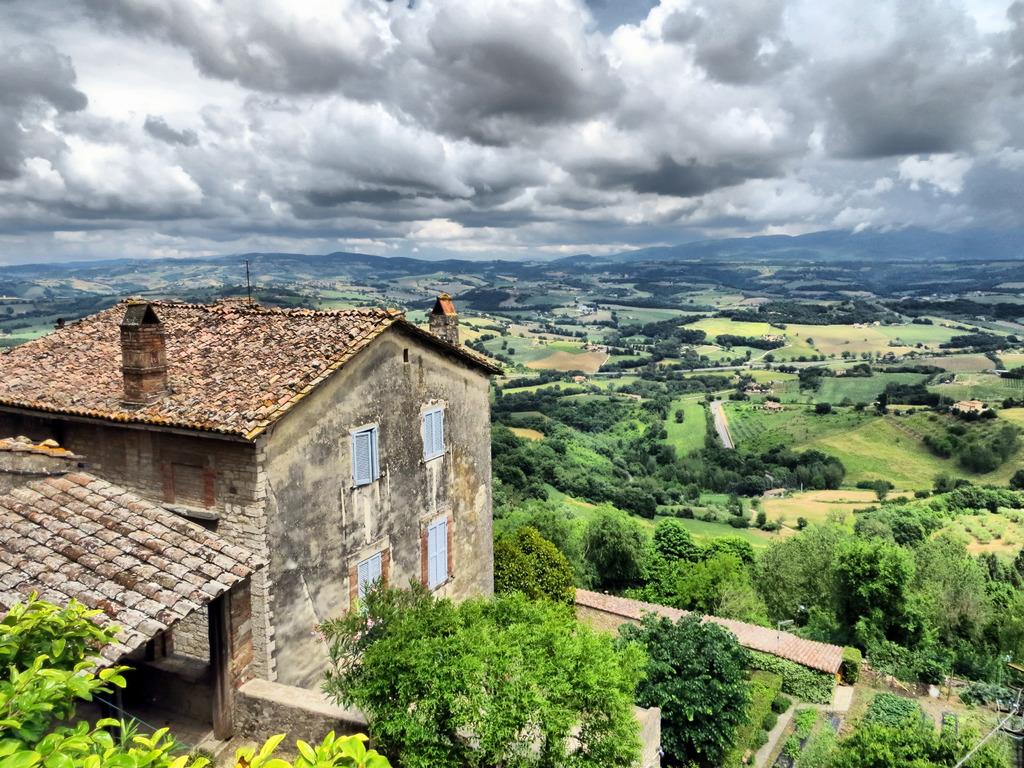What type of structure is present in the image? There is a building in the image. What type of vegetation can be seen in the image? There are trees and grass in the image. What part of the natural environment is visible in the image? The sky is visible in the image. How would you describe the sky in the image? The sky appears to be cloudy in the image. What type of plantation is visible in the image? There is no plantation present in the image. What is being used to serve the drinks in the image? There is no tray or drinks present in the image. 